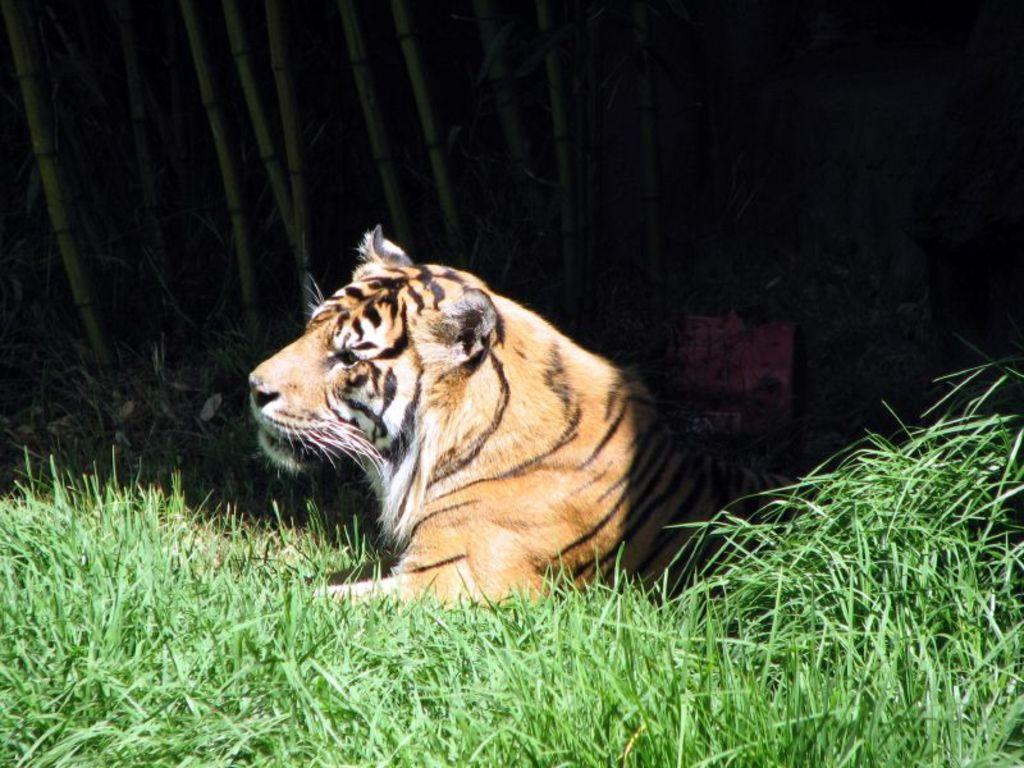What animal is the main subject of the picture? There is a tiger in the picture. What type of surface is the tiger standing on? The tiger is on the grass floor. Can you hear the tiger laughing in the picture? There is no sound in the picture, so it is not possible to hear the tiger laughing. 